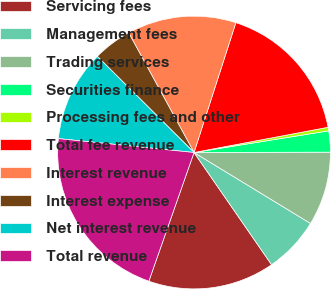Convert chart. <chart><loc_0><loc_0><loc_500><loc_500><pie_chart><fcel>Servicing fees<fcel>Management fees<fcel>Trading services<fcel>Securities finance<fcel>Processing fees and other<fcel>Total fee revenue<fcel>Interest revenue<fcel>Interest expense<fcel>Net interest revenue<fcel>Total revenue<nl><fcel>15.0%<fcel>6.67%<fcel>8.75%<fcel>2.5%<fcel>0.42%<fcel>17.08%<fcel>12.92%<fcel>4.59%<fcel>10.83%<fcel>21.25%<nl></chart> 